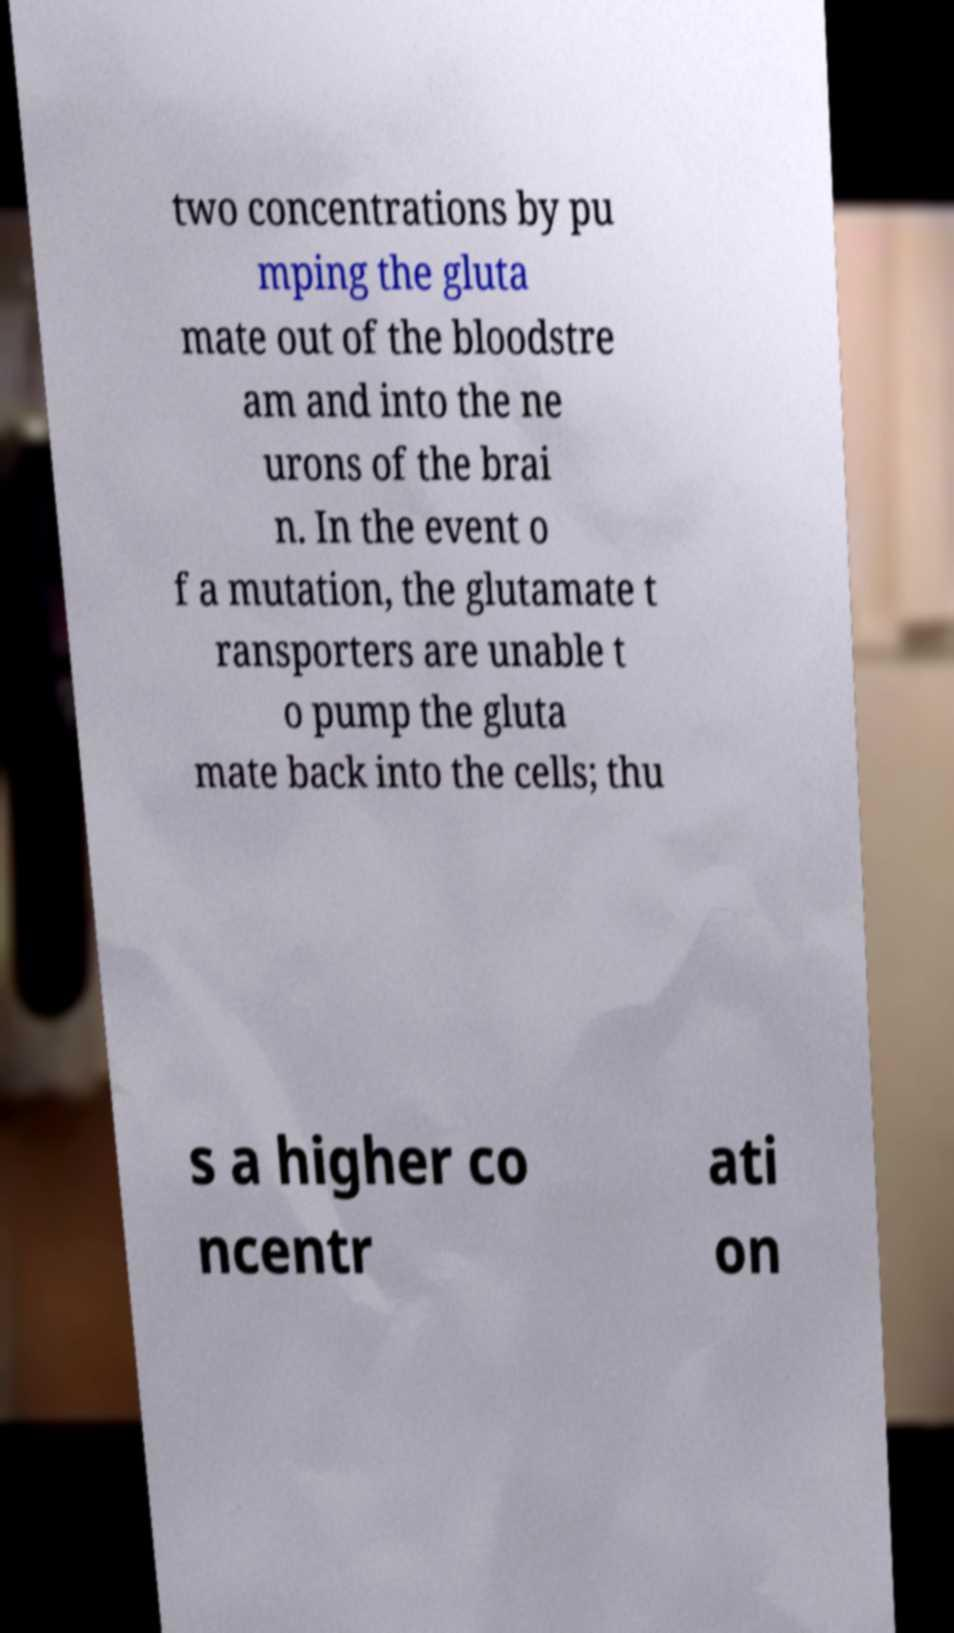Can you read and provide the text displayed in the image?This photo seems to have some interesting text. Can you extract and type it out for me? two concentrations by pu mping the gluta mate out of the bloodstre am and into the ne urons of the brai n. In the event o f a mutation, the glutamate t ransporters are unable t o pump the gluta mate back into the cells; thu s a higher co ncentr ati on 